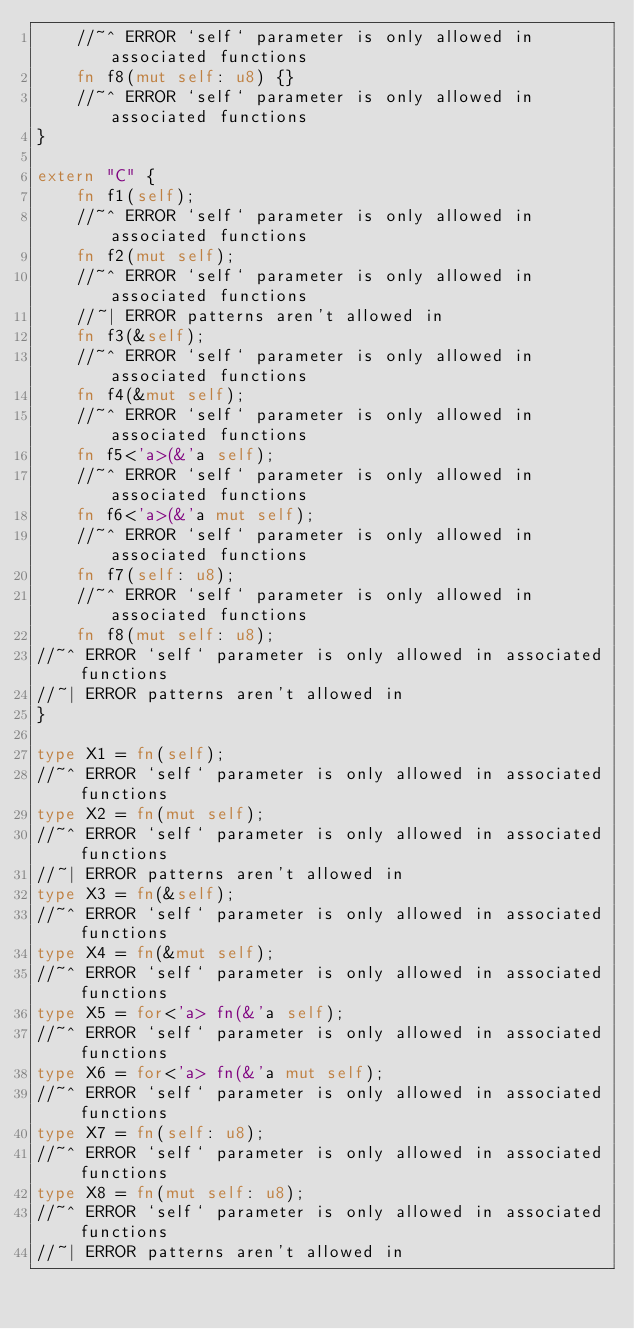Convert code to text. <code><loc_0><loc_0><loc_500><loc_500><_Rust_>    //~^ ERROR `self` parameter is only allowed in associated functions
    fn f8(mut self: u8) {}
    //~^ ERROR `self` parameter is only allowed in associated functions
}

extern "C" {
    fn f1(self);
    //~^ ERROR `self` parameter is only allowed in associated functions
    fn f2(mut self);
    //~^ ERROR `self` parameter is only allowed in associated functions
    //~| ERROR patterns aren't allowed in
    fn f3(&self);
    //~^ ERROR `self` parameter is only allowed in associated functions
    fn f4(&mut self);
    //~^ ERROR `self` parameter is only allowed in associated functions
    fn f5<'a>(&'a self);
    //~^ ERROR `self` parameter is only allowed in associated functions
    fn f6<'a>(&'a mut self);
    //~^ ERROR `self` parameter is only allowed in associated functions
    fn f7(self: u8);
    //~^ ERROR `self` parameter is only allowed in associated functions
    fn f8(mut self: u8);
//~^ ERROR `self` parameter is only allowed in associated functions
//~| ERROR patterns aren't allowed in
}

type X1 = fn(self);
//~^ ERROR `self` parameter is only allowed in associated functions
type X2 = fn(mut self);
//~^ ERROR `self` parameter is only allowed in associated functions
//~| ERROR patterns aren't allowed in
type X3 = fn(&self);
//~^ ERROR `self` parameter is only allowed in associated functions
type X4 = fn(&mut self);
//~^ ERROR `self` parameter is only allowed in associated functions
type X5 = for<'a> fn(&'a self);
//~^ ERROR `self` parameter is only allowed in associated functions
type X6 = for<'a> fn(&'a mut self);
//~^ ERROR `self` parameter is only allowed in associated functions
type X7 = fn(self: u8);
//~^ ERROR `self` parameter is only allowed in associated functions
type X8 = fn(mut self: u8);
//~^ ERROR `self` parameter is only allowed in associated functions
//~| ERROR patterns aren't allowed in
</code> 